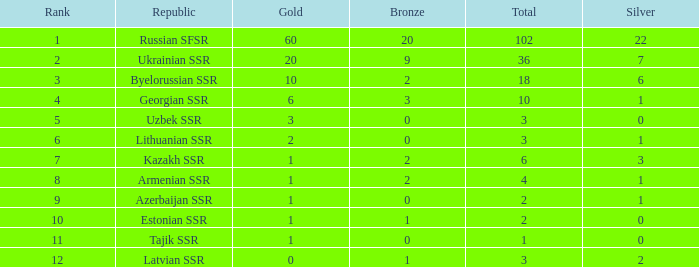What is the total number of bronzes associated with 1 silver, ranks under 6 and under 6 golds? None. 